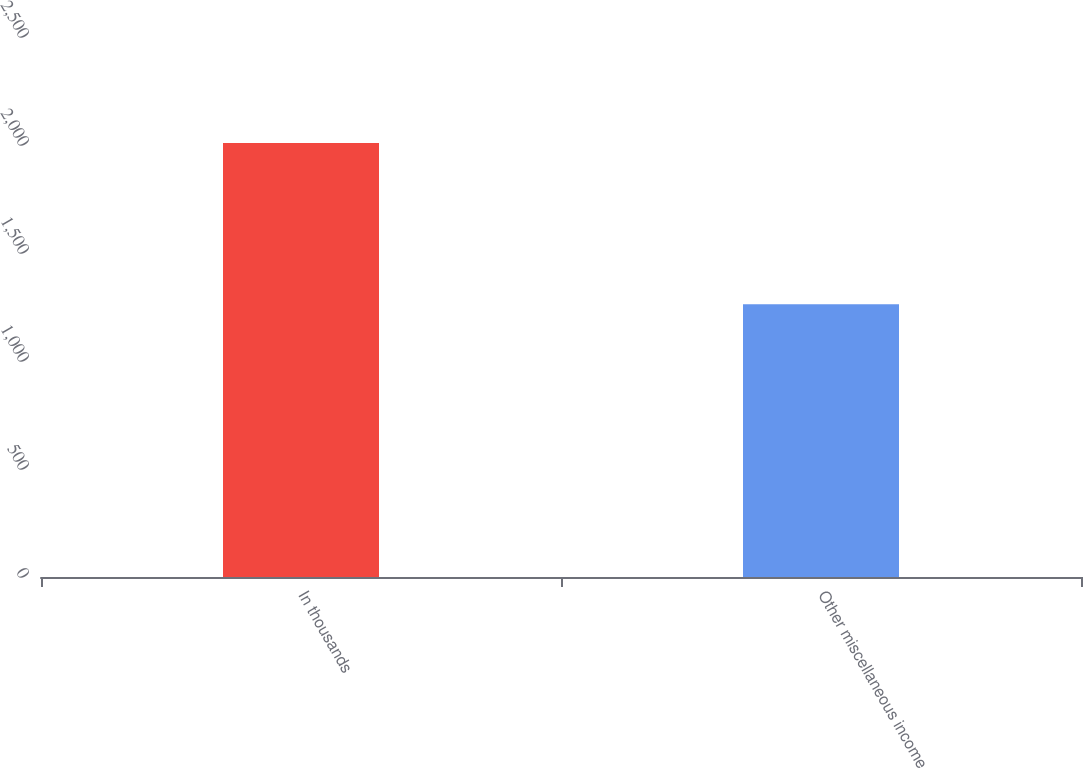<chart> <loc_0><loc_0><loc_500><loc_500><bar_chart><fcel>In thousands<fcel>Other miscellaneous income<nl><fcel>2009<fcel>1263<nl></chart> 